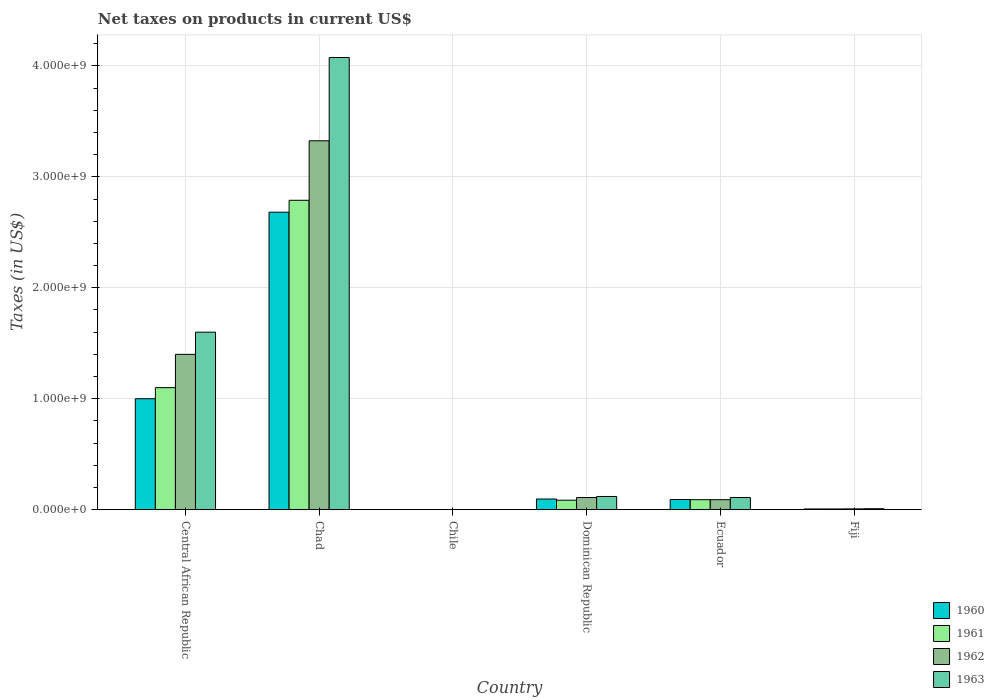How many groups of bars are there?
Your response must be concise. 6. Are the number of bars per tick equal to the number of legend labels?
Make the answer very short. Yes. Are the number of bars on each tick of the X-axis equal?
Give a very brief answer. Yes. What is the label of the 1st group of bars from the left?
Provide a short and direct response. Central African Republic. What is the net taxes on products in 1963 in Ecuador?
Offer a terse response. 1.10e+08. Across all countries, what is the maximum net taxes on products in 1960?
Provide a short and direct response. 2.68e+09. Across all countries, what is the minimum net taxes on products in 1962?
Provide a succinct answer. 2.53e+05. In which country was the net taxes on products in 1962 maximum?
Provide a succinct answer. Chad. In which country was the net taxes on products in 1961 minimum?
Provide a succinct answer. Chile. What is the total net taxes on products in 1961 in the graph?
Offer a terse response. 4.07e+09. What is the difference between the net taxes on products in 1960 in Central African Republic and that in Chile?
Keep it short and to the point. 1.00e+09. What is the difference between the net taxes on products in 1960 in Dominican Republic and the net taxes on products in 1962 in Ecuador?
Your answer should be compact. 6.18e+06. What is the average net taxes on products in 1961 per country?
Keep it short and to the point. 6.79e+08. What is the difference between the net taxes on products of/in 1960 and net taxes on products of/in 1961 in Ecuador?
Make the answer very short. 1.67e+06. In how many countries, is the net taxes on products in 1961 greater than 600000000 US$?
Your answer should be very brief. 2. What is the ratio of the net taxes on products in 1961 in Central African Republic to that in Chile?
Your response must be concise. 4346.11. What is the difference between the highest and the second highest net taxes on products in 1960?
Your answer should be compact. -9.04e+08. What is the difference between the highest and the lowest net taxes on products in 1963?
Your response must be concise. 4.08e+09. In how many countries, is the net taxes on products in 1961 greater than the average net taxes on products in 1961 taken over all countries?
Your answer should be very brief. 2. Is the sum of the net taxes on products in 1961 in Central African Republic and Ecuador greater than the maximum net taxes on products in 1962 across all countries?
Ensure brevity in your answer.  No. Is it the case that in every country, the sum of the net taxes on products in 1961 and net taxes on products in 1962 is greater than the sum of net taxes on products in 1963 and net taxes on products in 1960?
Keep it short and to the point. No. What does the 2nd bar from the left in Chile represents?
Offer a very short reply. 1961. Is it the case that in every country, the sum of the net taxes on products in 1960 and net taxes on products in 1961 is greater than the net taxes on products in 1962?
Your response must be concise. Yes. How many bars are there?
Provide a short and direct response. 24. Are all the bars in the graph horizontal?
Provide a short and direct response. No. How many countries are there in the graph?
Your answer should be very brief. 6. Are the values on the major ticks of Y-axis written in scientific E-notation?
Your answer should be very brief. Yes. Does the graph contain any zero values?
Provide a short and direct response. No. Does the graph contain grids?
Your answer should be compact. Yes. Where does the legend appear in the graph?
Your answer should be very brief. Bottom right. How are the legend labels stacked?
Ensure brevity in your answer.  Vertical. What is the title of the graph?
Give a very brief answer. Net taxes on products in current US$. What is the label or title of the X-axis?
Your answer should be compact. Country. What is the label or title of the Y-axis?
Provide a short and direct response. Taxes (in US$). What is the Taxes (in US$) of 1960 in Central African Republic?
Offer a very short reply. 1.00e+09. What is the Taxes (in US$) in 1961 in Central African Republic?
Provide a short and direct response. 1.10e+09. What is the Taxes (in US$) of 1962 in Central African Republic?
Offer a very short reply. 1.40e+09. What is the Taxes (in US$) of 1963 in Central African Republic?
Your response must be concise. 1.60e+09. What is the Taxes (in US$) of 1960 in Chad?
Provide a short and direct response. 2.68e+09. What is the Taxes (in US$) of 1961 in Chad?
Your response must be concise. 2.79e+09. What is the Taxes (in US$) of 1962 in Chad?
Give a very brief answer. 3.32e+09. What is the Taxes (in US$) of 1963 in Chad?
Make the answer very short. 4.08e+09. What is the Taxes (in US$) in 1960 in Chile?
Make the answer very short. 2.02e+05. What is the Taxes (in US$) in 1961 in Chile?
Offer a very short reply. 2.53e+05. What is the Taxes (in US$) in 1962 in Chile?
Your answer should be very brief. 2.53e+05. What is the Taxes (in US$) of 1963 in Chile?
Your answer should be compact. 3.54e+05. What is the Taxes (in US$) of 1960 in Dominican Republic?
Your answer should be very brief. 9.64e+07. What is the Taxes (in US$) of 1961 in Dominican Republic?
Offer a terse response. 8.56e+07. What is the Taxes (in US$) in 1962 in Dominican Republic?
Give a very brief answer. 1.10e+08. What is the Taxes (in US$) of 1963 in Dominican Republic?
Your answer should be compact. 1.19e+08. What is the Taxes (in US$) in 1960 in Ecuador?
Give a very brief answer. 9.19e+07. What is the Taxes (in US$) of 1961 in Ecuador?
Your response must be concise. 9.02e+07. What is the Taxes (in US$) in 1962 in Ecuador?
Your answer should be very brief. 9.02e+07. What is the Taxes (in US$) in 1963 in Ecuador?
Keep it short and to the point. 1.10e+08. What is the Taxes (in US$) in 1960 in Fiji?
Your answer should be compact. 6.80e+06. What is the Taxes (in US$) in 1961 in Fiji?
Offer a very short reply. 6.80e+06. What is the Taxes (in US$) in 1962 in Fiji?
Offer a terse response. 7.40e+06. What is the Taxes (in US$) in 1963 in Fiji?
Your answer should be very brief. 8.90e+06. Across all countries, what is the maximum Taxes (in US$) in 1960?
Offer a terse response. 2.68e+09. Across all countries, what is the maximum Taxes (in US$) of 1961?
Give a very brief answer. 2.79e+09. Across all countries, what is the maximum Taxes (in US$) in 1962?
Provide a short and direct response. 3.32e+09. Across all countries, what is the maximum Taxes (in US$) in 1963?
Ensure brevity in your answer.  4.08e+09. Across all countries, what is the minimum Taxes (in US$) of 1960?
Ensure brevity in your answer.  2.02e+05. Across all countries, what is the minimum Taxes (in US$) in 1961?
Offer a very short reply. 2.53e+05. Across all countries, what is the minimum Taxes (in US$) of 1962?
Give a very brief answer. 2.53e+05. Across all countries, what is the minimum Taxes (in US$) of 1963?
Make the answer very short. 3.54e+05. What is the total Taxes (in US$) in 1960 in the graph?
Offer a very short reply. 3.88e+09. What is the total Taxes (in US$) of 1961 in the graph?
Offer a very short reply. 4.07e+09. What is the total Taxes (in US$) of 1962 in the graph?
Offer a terse response. 4.93e+09. What is the total Taxes (in US$) in 1963 in the graph?
Keep it short and to the point. 5.91e+09. What is the difference between the Taxes (in US$) of 1960 in Central African Republic and that in Chad?
Keep it short and to the point. -1.68e+09. What is the difference between the Taxes (in US$) in 1961 in Central African Republic and that in Chad?
Your answer should be compact. -1.69e+09. What is the difference between the Taxes (in US$) in 1962 in Central African Republic and that in Chad?
Your response must be concise. -1.92e+09. What is the difference between the Taxes (in US$) of 1963 in Central African Republic and that in Chad?
Keep it short and to the point. -2.48e+09. What is the difference between the Taxes (in US$) in 1960 in Central African Republic and that in Chile?
Your response must be concise. 1.00e+09. What is the difference between the Taxes (in US$) in 1961 in Central African Republic and that in Chile?
Keep it short and to the point. 1.10e+09. What is the difference between the Taxes (in US$) of 1962 in Central African Republic and that in Chile?
Make the answer very short. 1.40e+09. What is the difference between the Taxes (in US$) in 1963 in Central African Republic and that in Chile?
Offer a terse response. 1.60e+09. What is the difference between the Taxes (in US$) in 1960 in Central African Republic and that in Dominican Republic?
Your response must be concise. 9.04e+08. What is the difference between the Taxes (in US$) of 1961 in Central African Republic and that in Dominican Republic?
Offer a very short reply. 1.01e+09. What is the difference between the Taxes (in US$) of 1962 in Central African Republic and that in Dominican Republic?
Ensure brevity in your answer.  1.29e+09. What is the difference between the Taxes (in US$) of 1963 in Central African Republic and that in Dominican Republic?
Your response must be concise. 1.48e+09. What is the difference between the Taxes (in US$) in 1960 in Central African Republic and that in Ecuador?
Offer a very short reply. 9.08e+08. What is the difference between the Taxes (in US$) of 1961 in Central African Republic and that in Ecuador?
Provide a short and direct response. 1.01e+09. What is the difference between the Taxes (in US$) of 1962 in Central African Republic and that in Ecuador?
Offer a terse response. 1.31e+09. What is the difference between the Taxes (in US$) in 1963 in Central African Republic and that in Ecuador?
Make the answer very short. 1.49e+09. What is the difference between the Taxes (in US$) of 1960 in Central African Republic and that in Fiji?
Your answer should be very brief. 9.93e+08. What is the difference between the Taxes (in US$) in 1961 in Central African Republic and that in Fiji?
Offer a terse response. 1.09e+09. What is the difference between the Taxes (in US$) of 1962 in Central African Republic and that in Fiji?
Offer a terse response. 1.39e+09. What is the difference between the Taxes (in US$) of 1963 in Central African Republic and that in Fiji?
Provide a short and direct response. 1.59e+09. What is the difference between the Taxes (in US$) in 1960 in Chad and that in Chile?
Your answer should be very brief. 2.68e+09. What is the difference between the Taxes (in US$) in 1961 in Chad and that in Chile?
Offer a terse response. 2.79e+09. What is the difference between the Taxes (in US$) in 1962 in Chad and that in Chile?
Make the answer very short. 3.32e+09. What is the difference between the Taxes (in US$) of 1963 in Chad and that in Chile?
Your answer should be very brief. 4.08e+09. What is the difference between the Taxes (in US$) in 1960 in Chad and that in Dominican Republic?
Your response must be concise. 2.58e+09. What is the difference between the Taxes (in US$) of 1961 in Chad and that in Dominican Republic?
Make the answer very short. 2.70e+09. What is the difference between the Taxes (in US$) of 1962 in Chad and that in Dominican Republic?
Your response must be concise. 3.22e+09. What is the difference between the Taxes (in US$) in 1963 in Chad and that in Dominican Republic?
Your answer should be very brief. 3.96e+09. What is the difference between the Taxes (in US$) in 1960 in Chad and that in Ecuador?
Offer a very short reply. 2.59e+09. What is the difference between the Taxes (in US$) of 1961 in Chad and that in Ecuador?
Ensure brevity in your answer.  2.70e+09. What is the difference between the Taxes (in US$) of 1962 in Chad and that in Ecuador?
Make the answer very short. 3.23e+09. What is the difference between the Taxes (in US$) of 1963 in Chad and that in Ecuador?
Ensure brevity in your answer.  3.97e+09. What is the difference between the Taxes (in US$) of 1960 in Chad and that in Fiji?
Provide a succinct answer. 2.67e+09. What is the difference between the Taxes (in US$) in 1961 in Chad and that in Fiji?
Your answer should be compact. 2.78e+09. What is the difference between the Taxes (in US$) of 1962 in Chad and that in Fiji?
Ensure brevity in your answer.  3.32e+09. What is the difference between the Taxes (in US$) in 1963 in Chad and that in Fiji?
Keep it short and to the point. 4.07e+09. What is the difference between the Taxes (in US$) in 1960 in Chile and that in Dominican Republic?
Keep it short and to the point. -9.62e+07. What is the difference between the Taxes (in US$) of 1961 in Chile and that in Dominican Republic?
Your answer should be very brief. -8.53e+07. What is the difference between the Taxes (in US$) in 1962 in Chile and that in Dominican Republic?
Give a very brief answer. -1.09e+08. What is the difference between the Taxes (in US$) in 1963 in Chile and that in Dominican Republic?
Ensure brevity in your answer.  -1.19e+08. What is the difference between the Taxes (in US$) of 1960 in Chile and that in Ecuador?
Offer a terse response. -9.17e+07. What is the difference between the Taxes (in US$) in 1961 in Chile and that in Ecuador?
Make the answer very short. -9.00e+07. What is the difference between the Taxes (in US$) of 1962 in Chile and that in Ecuador?
Ensure brevity in your answer.  -9.00e+07. What is the difference between the Taxes (in US$) in 1963 in Chile and that in Ecuador?
Your answer should be very brief. -1.09e+08. What is the difference between the Taxes (in US$) in 1960 in Chile and that in Fiji?
Give a very brief answer. -6.60e+06. What is the difference between the Taxes (in US$) in 1961 in Chile and that in Fiji?
Give a very brief answer. -6.55e+06. What is the difference between the Taxes (in US$) of 1962 in Chile and that in Fiji?
Provide a short and direct response. -7.15e+06. What is the difference between the Taxes (in US$) of 1963 in Chile and that in Fiji?
Keep it short and to the point. -8.55e+06. What is the difference between the Taxes (in US$) of 1960 in Dominican Republic and that in Ecuador?
Offer a very short reply. 4.51e+06. What is the difference between the Taxes (in US$) in 1961 in Dominican Republic and that in Ecuador?
Offer a terse response. -4.62e+06. What is the difference between the Taxes (in US$) of 1962 in Dominican Republic and that in Ecuador?
Provide a succinct answer. 1.94e+07. What is the difference between the Taxes (in US$) of 1963 in Dominican Republic and that in Ecuador?
Keep it short and to the point. 9.49e+06. What is the difference between the Taxes (in US$) in 1960 in Dominican Republic and that in Fiji?
Your answer should be very brief. 8.96e+07. What is the difference between the Taxes (in US$) of 1961 in Dominican Republic and that in Fiji?
Ensure brevity in your answer.  7.88e+07. What is the difference between the Taxes (in US$) in 1962 in Dominican Republic and that in Fiji?
Ensure brevity in your answer.  1.02e+08. What is the difference between the Taxes (in US$) in 1963 in Dominican Republic and that in Fiji?
Offer a very short reply. 1.10e+08. What is the difference between the Taxes (in US$) in 1960 in Ecuador and that in Fiji?
Your response must be concise. 8.51e+07. What is the difference between the Taxes (in US$) in 1961 in Ecuador and that in Fiji?
Your response must be concise. 8.34e+07. What is the difference between the Taxes (in US$) in 1962 in Ecuador and that in Fiji?
Ensure brevity in your answer.  8.28e+07. What is the difference between the Taxes (in US$) of 1963 in Ecuador and that in Fiji?
Provide a succinct answer. 1.01e+08. What is the difference between the Taxes (in US$) of 1960 in Central African Republic and the Taxes (in US$) of 1961 in Chad?
Your answer should be very brief. -1.79e+09. What is the difference between the Taxes (in US$) of 1960 in Central African Republic and the Taxes (in US$) of 1962 in Chad?
Provide a succinct answer. -2.32e+09. What is the difference between the Taxes (in US$) of 1960 in Central African Republic and the Taxes (in US$) of 1963 in Chad?
Keep it short and to the point. -3.08e+09. What is the difference between the Taxes (in US$) of 1961 in Central African Republic and the Taxes (in US$) of 1962 in Chad?
Offer a terse response. -2.22e+09. What is the difference between the Taxes (in US$) of 1961 in Central African Republic and the Taxes (in US$) of 1963 in Chad?
Your answer should be compact. -2.98e+09. What is the difference between the Taxes (in US$) of 1962 in Central African Republic and the Taxes (in US$) of 1963 in Chad?
Ensure brevity in your answer.  -2.68e+09. What is the difference between the Taxes (in US$) of 1960 in Central African Republic and the Taxes (in US$) of 1961 in Chile?
Make the answer very short. 1.00e+09. What is the difference between the Taxes (in US$) in 1960 in Central African Republic and the Taxes (in US$) in 1962 in Chile?
Offer a terse response. 1.00e+09. What is the difference between the Taxes (in US$) in 1960 in Central African Republic and the Taxes (in US$) in 1963 in Chile?
Provide a short and direct response. 1.00e+09. What is the difference between the Taxes (in US$) of 1961 in Central African Republic and the Taxes (in US$) of 1962 in Chile?
Ensure brevity in your answer.  1.10e+09. What is the difference between the Taxes (in US$) in 1961 in Central African Republic and the Taxes (in US$) in 1963 in Chile?
Your answer should be very brief. 1.10e+09. What is the difference between the Taxes (in US$) of 1962 in Central African Republic and the Taxes (in US$) of 1963 in Chile?
Your answer should be very brief. 1.40e+09. What is the difference between the Taxes (in US$) in 1960 in Central African Republic and the Taxes (in US$) in 1961 in Dominican Republic?
Ensure brevity in your answer.  9.14e+08. What is the difference between the Taxes (in US$) of 1960 in Central African Republic and the Taxes (in US$) of 1962 in Dominican Republic?
Provide a short and direct response. 8.90e+08. What is the difference between the Taxes (in US$) in 1960 in Central African Republic and the Taxes (in US$) in 1963 in Dominican Republic?
Keep it short and to the point. 8.81e+08. What is the difference between the Taxes (in US$) of 1961 in Central African Republic and the Taxes (in US$) of 1962 in Dominican Republic?
Your answer should be compact. 9.90e+08. What is the difference between the Taxes (in US$) in 1961 in Central African Republic and the Taxes (in US$) in 1963 in Dominican Republic?
Make the answer very short. 9.81e+08. What is the difference between the Taxes (in US$) in 1962 in Central African Republic and the Taxes (in US$) in 1963 in Dominican Republic?
Offer a very short reply. 1.28e+09. What is the difference between the Taxes (in US$) of 1960 in Central African Republic and the Taxes (in US$) of 1961 in Ecuador?
Ensure brevity in your answer.  9.10e+08. What is the difference between the Taxes (in US$) of 1960 in Central African Republic and the Taxes (in US$) of 1962 in Ecuador?
Provide a succinct answer. 9.10e+08. What is the difference between the Taxes (in US$) of 1960 in Central African Republic and the Taxes (in US$) of 1963 in Ecuador?
Your answer should be compact. 8.90e+08. What is the difference between the Taxes (in US$) of 1961 in Central African Republic and the Taxes (in US$) of 1962 in Ecuador?
Your response must be concise. 1.01e+09. What is the difference between the Taxes (in US$) in 1961 in Central African Republic and the Taxes (in US$) in 1963 in Ecuador?
Keep it short and to the point. 9.90e+08. What is the difference between the Taxes (in US$) of 1962 in Central African Republic and the Taxes (in US$) of 1963 in Ecuador?
Make the answer very short. 1.29e+09. What is the difference between the Taxes (in US$) of 1960 in Central African Republic and the Taxes (in US$) of 1961 in Fiji?
Offer a very short reply. 9.93e+08. What is the difference between the Taxes (in US$) of 1960 in Central African Republic and the Taxes (in US$) of 1962 in Fiji?
Your answer should be very brief. 9.93e+08. What is the difference between the Taxes (in US$) in 1960 in Central African Republic and the Taxes (in US$) in 1963 in Fiji?
Keep it short and to the point. 9.91e+08. What is the difference between the Taxes (in US$) of 1961 in Central African Republic and the Taxes (in US$) of 1962 in Fiji?
Ensure brevity in your answer.  1.09e+09. What is the difference between the Taxes (in US$) in 1961 in Central African Republic and the Taxes (in US$) in 1963 in Fiji?
Offer a terse response. 1.09e+09. What is the difference between the Taxes (in US$) of 1962 in Central African Republic and the Taxes (in US$) of 1963 in Fiji?
Provide a short and direct response. 1.39e+09. What is the difference between the Taxes (in US$) of 1960 in Chad and the Taxes (in US$) of 1961 in Chile?
Your response must be concise. 2.68e+09. What is the difference between the Taxes (in US$) of 1960 in Chad and the Taxes (in US$) of 1962 in Chile?
Your response must be concise. 2.68e+09. What is the difference between the Taxes (in US$) of 1960 in Chad and the Taxes (in US$) of 1963 in Chile?
Offer a terse response. 2.68e+09. What is the difference between the Taxes (in US$) in 1961 in Chad and the Taxes (in US$) in 1962 in Chile?
Your answer should be very brief. 2.79e+09. What is the difference between the Taxes (in US$) of 1961 in Chad and the Taxes (in US$) of 1963 in Chile?
Your answer should be compact. 2.79e+09. What is the difference between the Taxes (in US$) of 1962 in Chad and the Taxes (in US$) of 1963 in Chile?
Provide a succinct answer. 3.32e+09. What is the difference between the Taxes (in US$) of 1960 in Chad and the Taxes (in US$) of 1961 in Dominican Republic?
Offer a terse response. 2.60e+09. What is the difference between the Taxes (in US$) of 1960 in Chad and the Taxes (in US$) of 1962 in Dominican Republic?
Your answer should be very brief. 2.57e+09. What is the difference between the Taxes (in US$) of 1960 in Chad and the Taxes (in US$) of 1963 in Dominican Republic?
Give a very brief answer. 2.56e+09. What is the difference between the Taxes (in US$) of 1961 in Chad and the Taxes (in US$) of 1962 in Dominican Republic?
Make the answer very short. 2.68e+09. What is the difference between the Taxes (in US$) of 1961 in Chad and the Taxes (in US$) of 1963 in Dominican Republic?
Make the answer very short. 2.67e+09. What is the difference between the Taxes (in US$) of 1962 in Chad and the Taxes (in US$) of 1963 in Dominican Republic?
Provide a succinct answer. 3.21e+09. What is the difference between the Taxes (in US$) of 1960 in Chad and the Taxes (in US$) of 1961 in Ecuador?
Provide a short and direct response. 2.59e+09. What is the difference between the Taxes (in US$) in 1960 in Chad and the Taxes (in US$) in 1962 in Ecuador?
Provide a short and direct response. 2.59e+09. What is the difference between the Taxes (in US$) of 1960 in Chad and the Taxes (in US$) of 1963 in Ecuador?
Offer a terse response. 2.57e+09. What is the difference between the Taxes (in US$) of 1961 in Chad and the Taxes (in US$) of 1962 in Ecuador?
Provide a short and direct response. 2.70e+09. What is the difference between the Taxes (in US$) in 1961 in Chad and the Taxes (in US$) in 1963 in Ecuador?
Give a very brief answer. 2.68e+09. What is the difference between the Taxes (in US$) in 1962 in Chad and the Taxes (in US$) in 1963 in Ecuador?
Offer a terse response. 3.22e+09. What is the difference between the Taxes (in US$) of 1960 in Chad and the Taxes (in US$) of 1961 in Fiji?
Your response must be concise. 2.67e+09. What is the difference between the Taxes (in US$) of 1960 in Chad and the Taxes (in US$) of 1962 in Fiji?
Keep it short and to the point. 2.67e+09. What is the difference between the Taxes (in US$) in 1960 in Chad and the Taxes (in US$) in 1963 in Fiji?
Offer a very short reply. 2.67e+09. What is the difference between the Taxes (in US$) of 1961 in Chad and the Taxes (in US$) of 1962 in Fiji?
Give a very brief answer. 2.78e+09. What is the difference between the Taxes (in US$) in 1961 in Chad and the Taxes (in US$) in 1963 in Fiji?
Your response must be concise. 2.78e+09. What is the difference between the Taxes (in US$) of 1962 in Chad and the Taxes (in US$) of 1963 in Fiji?
Provide a short and direct response. 3.32e+09. What is the difference between the Taxes (in US$) of 1960 in Chile and the Taxes (in US$) of 1961 in Dominican Republic?
Provide a succinct answer. -8.54e+07. What is the difference between the Taxes (in US$) in 1960 in Chile and the Taxes (in US$) in 1962 in Dominican Republic?
Ensure brevity in your answer.  -1.09e+08. What is the difference between the Taxes (in US$) in 1960 in Chile and the Taxes (in US$) in 1963 in Dominican Republic?
Give a very brief answer. -1.19e+08. What is the difference between the Taxes (in US$) in 1961 in Chile and the Taxes (in US$) in 1962 in Dominican Republic?
Keep it short and to the point. -1.09e+08. What is the difference between the Taxes (in US$) of 1961 in Chile and the Taxes (in US$) of 1963 in Dominican Republic?
Keep it short and to the point. -1.19e+08. What is the difference between the Taxes (in US$) of 1962 in Chile and the Taxes (in US$) of 1963 in Dominican Republic?
Provide a short and direct response. -1.19e+08. What is the difference between the Taxes (in US$) of 1960 in Chile and the Taxes (in US$) of 1961 in Ecuador?
Make the answer very short. -9.00e+07. What is the difference between the Taxes (in US$) of 1960 in Chile and the Taxes (in US$) of 1962 in Ecuador?
Your answer should be compact. -9.00e+07. What is the difference between the Taxes (in US$) of 1960 in Chile and the Taxes (in US$) of 1963 in Ecuador?
Your answer should be very brief. -1.10e+08. What is the difference between the Taxes (in US$) in 1961 in Chile and the Taxes (in US$) in 1962 in Ecuador?
Your response must be concise. -9.00e+07. What is the difference between the Taxes (in US$) in 1961 in Chile and the Taxes (in US$) in 1963 in Ecuador?
Offer a very short reply. -1.09e+08. What is the difference between the Taxes (in US$) of 1962 in Chile and the Taxes (in US$) of 1963 in Ecuador?
Offer a terse response. -1.09e+08. What is the difference between the Taxes (in US$) of 1960 in Chile and the Taxes (in US$) of 1961 in Fiji?
Your answer should be very brief. -6.60e+06. What is the difference between the Taxes (in US$) of 1960 in Chile and the Taxes (in US$) of 1962 in Fiji?
Your answer should be very brief. -7.20e+06. What is the difference between the Taxes (in US$) in 1960 in Chile and the Taxes (in US$) in 1963 in Fiji?
Ensure brevity in your answer.  -8.70e+06. What is the difference between the Taxes (in US$) in 1961 in Chile and the Taxes (in US$) in 1962 in Fiji?
Offer a very short reply. -7.15e+06. What is the difference between the Taxes (in US$) in 1961 in Chile and the Taxes (in US$) in 1963 in Fiji?
Provide a short and direct response. -8.65e+06. What is the difference between the Taxes (in US$) of 1962 in Chile and the Taxes (in US$) of 1963 in Fiji?
Offer a terse response. -8.65e+06. What is the difference between the Taxes (in US$) of 1960 in Dominican Republic and the Taxes (in US$) of 1961 in Ecuador?
Ensure brevity in your answer.  6.18e+06. What is the difference between the Taxes (in US$) of 1960 in Dominican Republic and the Taxes (in US$) of 1962 in Ecuador?
Your answer should be compact. 6.18e+06. What is the difference between the Taxes (in US$) of 1960 in Dominican Republic and the Taxes (in US$) of 1963 in Ecuador?
Give a very brief answer. -1.33e+07. What is the difference between the Taxes (in US$) in 1961 in Dominican Republic and the Taxes (in US$) in 1962 in Ecuador?
Offer a terse response. -4.62e+06. What is the difference between the Taxes (in US$) of 1961 in Dominican Republic and the Taxes (in US$) of 1963 in Ecuador?
Make the answer very short. -2.41e+07. What is the difference between the Taxes (in US$) of 1962 in Dominican Republic and the Taxes (in US$) of 1963 in Ecuador?
Your answer should be very brief. -1.11e+05. What is the difference between the Taxes (in US$) of 1960 in Dominican Republic and the Taxes (in US$) of 1961 in Fiji?
Your response must be concise. 8.96e+07. What is the difference between the Taxes (in US$) of 1960 in Dominican Republic and the Taxes (in US$) of 1962 in Fiji?
Offer a terse response. 8.90e+07. What is the difference between the Taxes (in US$) of 1960 in Dominican Republic and the Taxes (in US$) of 1963 in Fiji?
Offer a terse response. 8.75e+07. What is the difference between the Taxes (in US$) of 1961 in Dominican Republic and the Taxes (in US$) of 1962 in Fiji?
Offer a very short reply. 7.82e+07. What is the difference between the Taxes (in US$) of 1961 in Dominican Republic and the Taxes (in US$) of 1963 in Fiji?
Ensure brevity in your answer.  7.67e+07. What is the difference between the Taxes (in US$) of 1962 in Dominican Republic and the Taxes (in US$) of 1963 in Fiji?
Offer a terse response. 1.01e+08. What is the difference between the Taxes (in US$) in 1960 in Ecuador and the Taxes (in US$) in 1961 in Fiji?
Provide a short and direct response. 8.51e+07. What is the difference between the Taxes (in US$) in 1960 in Ecuador and the Taxes (in US$) in 1962 in Fiji?
Provide a succinct answer. 8.45e+07. What is the difference between the Taxes (in US$) in 1960 in Ecuador and the Taxes (in US$) in 1963 in Fiji?
Offer a very short reply. 8.30e+07. What is the difference between the Taxes (in US$) in 1961 in Ecuador and the Taxes (in US$) in 1962 in Fiji?
Your answer should be very brief. 8.28e+07. What is the difference between the Taxes (in US$) of 1961 in Ecuador and the Taxes (in US$) of 1963 in Fiji?
Your response must be concise. 8.13e+07. What is the difference between the Taxes (in US$) in 1962 in Ecuador and the Taxes (in US$) in 1963 in Fiji?
Provide a succinct answer. 8.13e+07. What is the average Taxes (in US$) of 1960 per country?
Offer a terse response. 6.46e+08. What is the average Taxes (in US$) of 1961 per country?
Your answer should be compact. 6.79e+08. What is the average Taxes (in US$) of 1962 per country?
Provide a succinct answer. 8.22e+08. What is the average Taxes (in US$) of 1963 per country?
Your answer should be very brief. 9.86e+08. What is the difference between the Taxes (in US$) of 1960 and Taxes (in US$) of 1961 in Central African Republic?
Your answer should be very brief. -1.00e+08. What is the difference between the Taxes (in US$) in 1960 and Taxes (in US$) in 1962 in Central African Republic?
Provide a succinct answer. -4.00e+08. What is the difference between the Taxes (in US$) in 1960 and Taxes (in US$) in 1963 in Central African Republic?
Offer a very short reply. -6.00e+08. What is the difference between the Taxes (in US$) of 1961 and Taxes (in US$) of 1962 in Central African Republic?
Your answer should be compact. -3.00e+08. What is the difference between the Taxes (in US$) of 1961 and Taxes (in US$) of 1963 in Central African Republic?
Your response must be concise. -5.00e+08. What is the difference between the Taxes (in US$) in 1962 and Taxes (in US$) in 1963 in Central African Republic?
Provide a succinct answer. -2.00e+08. What is the difference between the Taxes (in US$) of 1960 and Taxes (in US$) of 1961 in Chad?
Provide a succinct answer. -1.07e+08. What is the difference between the Taxes (in US$) of 1960 and Taxes (in US$) of 1962 in Chad?
Make the answer very short. -6.44e+08. What is the difference between the Taxes (in US$) of 1960 and Taxes (in US$) of 1963 in Chad?
Provide a short and direct response. -1.39e+09. What is the difference between the Taxes (in US$) in 1961 and Taxes (in US$) in 1962 in Chad?
Provide a succinct answer. -5.36e+08. What is the difference between the Taxes (in US$) in 1961 and Taxes (in US$) in 1963 in Chad?
Your answer should be very brief. -1.29e+09. What is the difference between the Taxes (in US$) in 1962 and Taxes (in US$) in 1963 in Chad?
Your answer should be very brief. -7.51e+08. What is the difference between the Taxes (in US$) in 1960 and Taxes (in US$) in 1961 in Chile?
Offer a terse response. -5.06e+04. What is the difference between the Taxes (in US$) of 1960 and Taxes (in US$) of 1962 in Chile?
Your answer should be very brief. -5.06e+04. What is the difference between the Taxes (in US$) of 1960 and Taxes (in US$) of 1963 in Chile?
Offer a terse response. -1.52e+05. What is the difference between the Taxes (in US$) in 1961 and Taxes (in US$) in 1963 in Chile?
Offer a terse response. -1.01e+05. What is the difference between the Taxes (in US$) in 1962 and Taxes (in US$) in 1963 in Chile?
Your response must be concise. -1.01e+05. What is the difference between the Taxes (in US$) of 1960 and Taxes (in US$) of 1961 in Dominican Republic?
Your answer should be very brief. 1.08e+07. What is the difference between the Taxes (in US$) of 1960 and Taxes (in US$) of 1962 in Dominican Republic?
Make the answer very short. -1.32e+07. What is the difference between the Taxes (in US$) in 1960 and Taxes (in US$) in 1963 in Dominican Republic?
Make the answer very short. -2.28e+07. What is the difference between the Taxes (in US$) of 1961 and Taxes (in US$) of 1962 in Dominican Republic?
Keep it short and to the point. -2.40e+07. What is the difference between the Taxes (in US$) of 1961 and Taxes (in US$) of 1963 in Dominican Republic?
Ensure brevity in your answer.  -3.36e+07. What is the difference between the Taxes (in US$) in 1962 and Taxes (in US$) in 1963 in Dominican Republic?
Your answer should be compact. -9.60e+06. What is the difference between the Taxes (in US$) in 1960 and Taxes (in US$) in 1961 in Ecuador?
Offer a terse response. 1.67e+06. What is the difference between the Taxes (in US$) of 1960 and Taxes (in US$) of 1962 in Ecuador?
Offer a terse response. 1.67e+06. What is the difference between the Taxes (in US$) in 1960 and Taxes (in US$) in 1963 in Ecuador?
Provide a short and direct response. -1.78e+07. What is the difference between the Taxes (in US$) in 1961 and Taxes (in US$) in 1963 in Ecuador?
Provide a short and direct response. -1.95e+07. What is the difference between the Taxes (in US$) in 1962 and Taxes (in US$) in 1963 in Ecuador?
Provide a short and direct response. -1.95e+07. What is the difference between the Taxes (in US$) in 1960 and Taxes (in US$) in 1962 in Fiji?
Give a very brief answer. -6.00e+05. What is the difference between the Taxes (in US$) of 1960 and Taxes (in US$) of 1963 in Fiji?
Ensure brevity in your answer.  -2.10e+06. What is the difference between the Taxes (in US$) in 1961 and Taxes (in US$) in 1962 in Fiji?
Your answer should be very brief. -6.00e+05. What is the difference between the Taxes (in US$) in 1961 and Taxes (in US$) in 1963 in Fiji?
Ensure brevity in your answer.  -2.10e+06. What is the difference between the Taxes (in US$) in 1962 and Taxes (in US$) in 1963 in Fiji?
Keep it short and to the point. -1.50e+06. What is the ratio of the Taxes (in US$) in 1960 in Central African Republic to that in Chad?
Ensure brevity in your answer.  0.37. What is the ratio of the Taxes (in US$) of 1961 in Central African Republic to that in Chad?
Keep it short and to the point. 0.39. What is the ratio of the Taxes (in US$) in 1962 in Central African Republic to that in Chad?
Offer a terse response. 0.42. What is the ratio of the Taxes (in US$) in 1963 in Central African Republic to that in Chad?
Your answer should be compact. 0.39. What is the ratio of the Taxes (in US$) of 1960 in Central African Republic to that in Chile?
Provide a short and direct response. 4938.27. What is the ratio of the Taxes (in US$) of 1961 in Central African Republic to that in Chile?
Offer a terse response. 4346.11. What is the ratio of the Taxes (in US$) of 1962 in Central African Republic to that in Chile?
Offer a terse response. 5531.41. What is the ratio of the Taxes (in US$) in 1963 in Central African Republic to that in Chile?
Offer a terse response. 4514.67. What is the ratio of the Taxes (in US$) of 1960 in Central African Republic to that in Dominican Republic?
Offer a terse response. 10.37. What is the ratio of the Taxes (in US$) of 1961 in Central African Republic to that in Dominican Republic?
Keep it short and to the point. 12.85. What is the ratio of the Taxes (in US$) of 1962 in Central African Republic to that in Dominican Republic?
Ensure brevity in your answer.  12.77. What is the ratio of the Taxes (in US$) in 1963 in Central African Republic to that in Dominican Republic?
Give a very brief answer. 13.42. What is the ratio of the Taxes (in US$) in 1960 in Central African Republic to that in Ecuador?
Provide a succinct answer. 10.88. What is the ratio of the Taxes (in US$) in 1961 in Central African Republic to that in Ecuador?
Provide a short and direct response. 12.19. What is the ratio of the Taxes (in US$) of 1962 in Central African Republic to that in Ecuador?
Offer a terse response. 15.52. What is the ratio of the Taxes (in US$) of 1963 in Central African Republic to that in Ecuador?
Provide a succinct answer. 14.58. What is the ratio of the Taxes (in US$) of 1960 in Central African Republic to that in Fiji?
Offer a very short reply. 147.06. What is the ratio of the Taxes (in US$) of 1961 in Central African Republic to that in Fiji?
Make the answer very short. 161.76. What is the ratio of the Taxes (in US$) of 1962 in Central African Republic to that in Fiji?
Ensure brevity in your answer.  189.19. What is the ratio of the Taxes (in US$) of 1963 in Central African Republic to that in Fiji?
Your response must be concise. 179.78. What is the ratio of the Taxes (in US$) in 1960 in Chad to that in Chile?
Provide a succinct answer. 1.32e+04. What is the ratio of the Taxes (in US$) of 1961 in Chad to that in Chile?
Your answer should be very brief. 1.10e+04. What is the ratio of the Taxes (in US$) in 1962 in Chad to that in Chile?
Your answer should be compact. 1.31e+04. What is the ratio of the Taxes (in US$) in 1963 in Chad to that in Chile?
Your answer should be compact. 1.15e+04. What is the ratio of the Taxes (in US$) of 1960 in Chad to that in Dominican Republic?
Ensure brevity in your answer.  27.81. What is the ratio of the Taxes (in US$) in 1961 in Chad to that in Dominican Republic?
Your response must be concise. 32.58. What is the ratio of the Taxes (in US$) of 1962 in Chad to that in Dominican Republic?
Keep it short and to the point. 30.34. What is the ratio of the Taxes (in US$) of 1963 in Chad to that in Dominican Republic?
Offer a very short reply. 34.19. What is the ratio of the Taxes (in US$) of 1960 in Chad to that in Ecuador?
Make the answer very short. 29.18. What is the ratio of the Taxes (in US$) of 1961 in Chad to that in Ecuador?
Provide a short and direct response. 30.91. What is the ratio of the Taxes (in US$) of 1962 in Chad to that in Ecuador?
Your answer should be very brief. 36.85. What is the ratio of the Taxes (in US$) of 1963 in Chad to that in Ecuador?
Provide a short and direct response. 37.15. What is the ratio of the Taxes (in US$) in 1960 in Chad to that in Fiji?
Provide a short and direct response. 394.3. What is the ratio of the Taxes (in US$) in 1961 in Chad to that in Fiji?
Provide a short and direct response. 410.08. What is the ratio of the Taxes (in US$) in 1962 in Chad to that in Fiji?
Your answer should be very brief. 449.29. What is the ratio of the Taxes (in US$) of 1963 in Chad to that in Fiji?
Provide a short and direct response. 457.92. What is the ratio of the Taxes (in US$) in 1960 in Chile to that in Dominican Republic?
Provide a succinct answer. 0. What is the ratio of the Taxes (in US$) in 1961 in Chile to that in Dominican Republic?
Offer a very short reply. 0. What is the ratio of the Taxes (in US$) of 1962 in Chile to that in Dominican Republic?
Your answer should be compact. 0. What is the ratio of the Taxes (in US$) of 1963 in Chile to that in Dominican Republic?
Your answer should be very brief. 0. What is the ratio of the Taxes (in US$) in 1960 in Chile to that in Ecuador?
Offer a very short reply. 0. What is the ratio of the Taxes (in US$) in 1961 in Chile to that in Ecuador?
Give a very brief answer. 0. What is the ratio of the Taxes (in US$) in 1962 in Chile to that in Ecuador?
Give a very brief answer. 0. What is the ratio of the Taxes (in US$) in 1963 in Chile to that in Ecuador?
Your answer should be very brief. 0. What is the ratio of the Taxes (in US$) in 1960 in Chile to that in Fiji?
Give a very brief answer. 0.03. What is the ratio of the Taxes (in US$) of 1961 in Chile to that in Fiji?
Give a very brief answer. 0.04. What is the ratio of the Taxes (in US$) in 1962 in Chile to that in Fiji?
Provide a succinct answer. 0.03. What is the ratio of the Taxes (in US$) of 1963 in Chile to that in Fiji?
Give a very brief answer. 0.04. What is the ratio of the Taxes (in US$) in 1960 in Dominican Republic to that in Ecuador?
Provide a succinct answer. 1.05. What is the ratio of the Taxes (in US$) of 1961 in Dominican Republic to that in Ecuador?
Keep it short and to the point. 0.95. What is the ratio of the Taxes (in US$) of 1962 in Dominican Republic to that in Ecuador?
Give a very brief answer. 1.21. What is the ratio of the Taxes (in US$) of 1963 in Dominican Republic to that in Ecuador?
Your response must be concise. 1.09. What is the ratio of the Taxes (in US$) in 1960 in Dominican Republic to that in Fiji?
Your response must be concise. 14.18. What is the ratio of the Taxes (in US$) in 1961 in Dominican Republic to that in Fiji?
Provide a succinct answer. 12.59. What is the ratio of the Taxes (in US$) of 1962 in Dominican Republic to that in Fiji?
Your answer should be very brief. 14.81. What is the ratio of the Taxes (in US$) in 1963 in Dominican Republic to that in Fiji?
Offer a very short reply. 13.39. What is the ratio of the Taxes (in US$) of 1960 in Ecuador to that in Fiji?
Keep it short and to the point. 13.51. What is the ratio of the Taxes (in US$) of 1961 in Ecuador to that in Fiji?
Your answer should be compact. 13.27. What is the ratio of the Taxes (in US$) in 1962 in Ecuador to that in Fiji?
Your answer should be very brief. 12.19. What is the ratio of the Taxes (in US$) of 1963 in Ecuador to that in Fiji?
Provide a short and direct response. 12.33. What is the difference between the highest and the second highest Taxes (in US$) of 1960?
Make the answer very short. 1.68e+09. What is the difference between the highest and the second highest Taxes (in US$) in 1961?
Your answer should be compact. 1.69e+09. What is the difference between the highest and the second highest Taxes (in US$) of 1962?
Provide a succinct answer. 1.92e+09. What is the difference between the highest and the second highest Taxes (in US$) in 1963?
Provide a succinct answer. 2.48e+09. What is the difference between the highest and the lowest Taxes (in US$) in 1960?
Ensure brevity in your answer.  2.68e+09. What is the difference between the highest and the lowest Taxes (in US$) of 1961?
Provide a succinct answer. 2.79e+09. What is the difference between the highest and the lowest Taxes (in US$) in 1962?
Offer a very short reply. 3.32e+09. What is the difference between the highest and the lowest Taxes (in US$) in 1963?
Make the answer very short. 4.08e+09. 